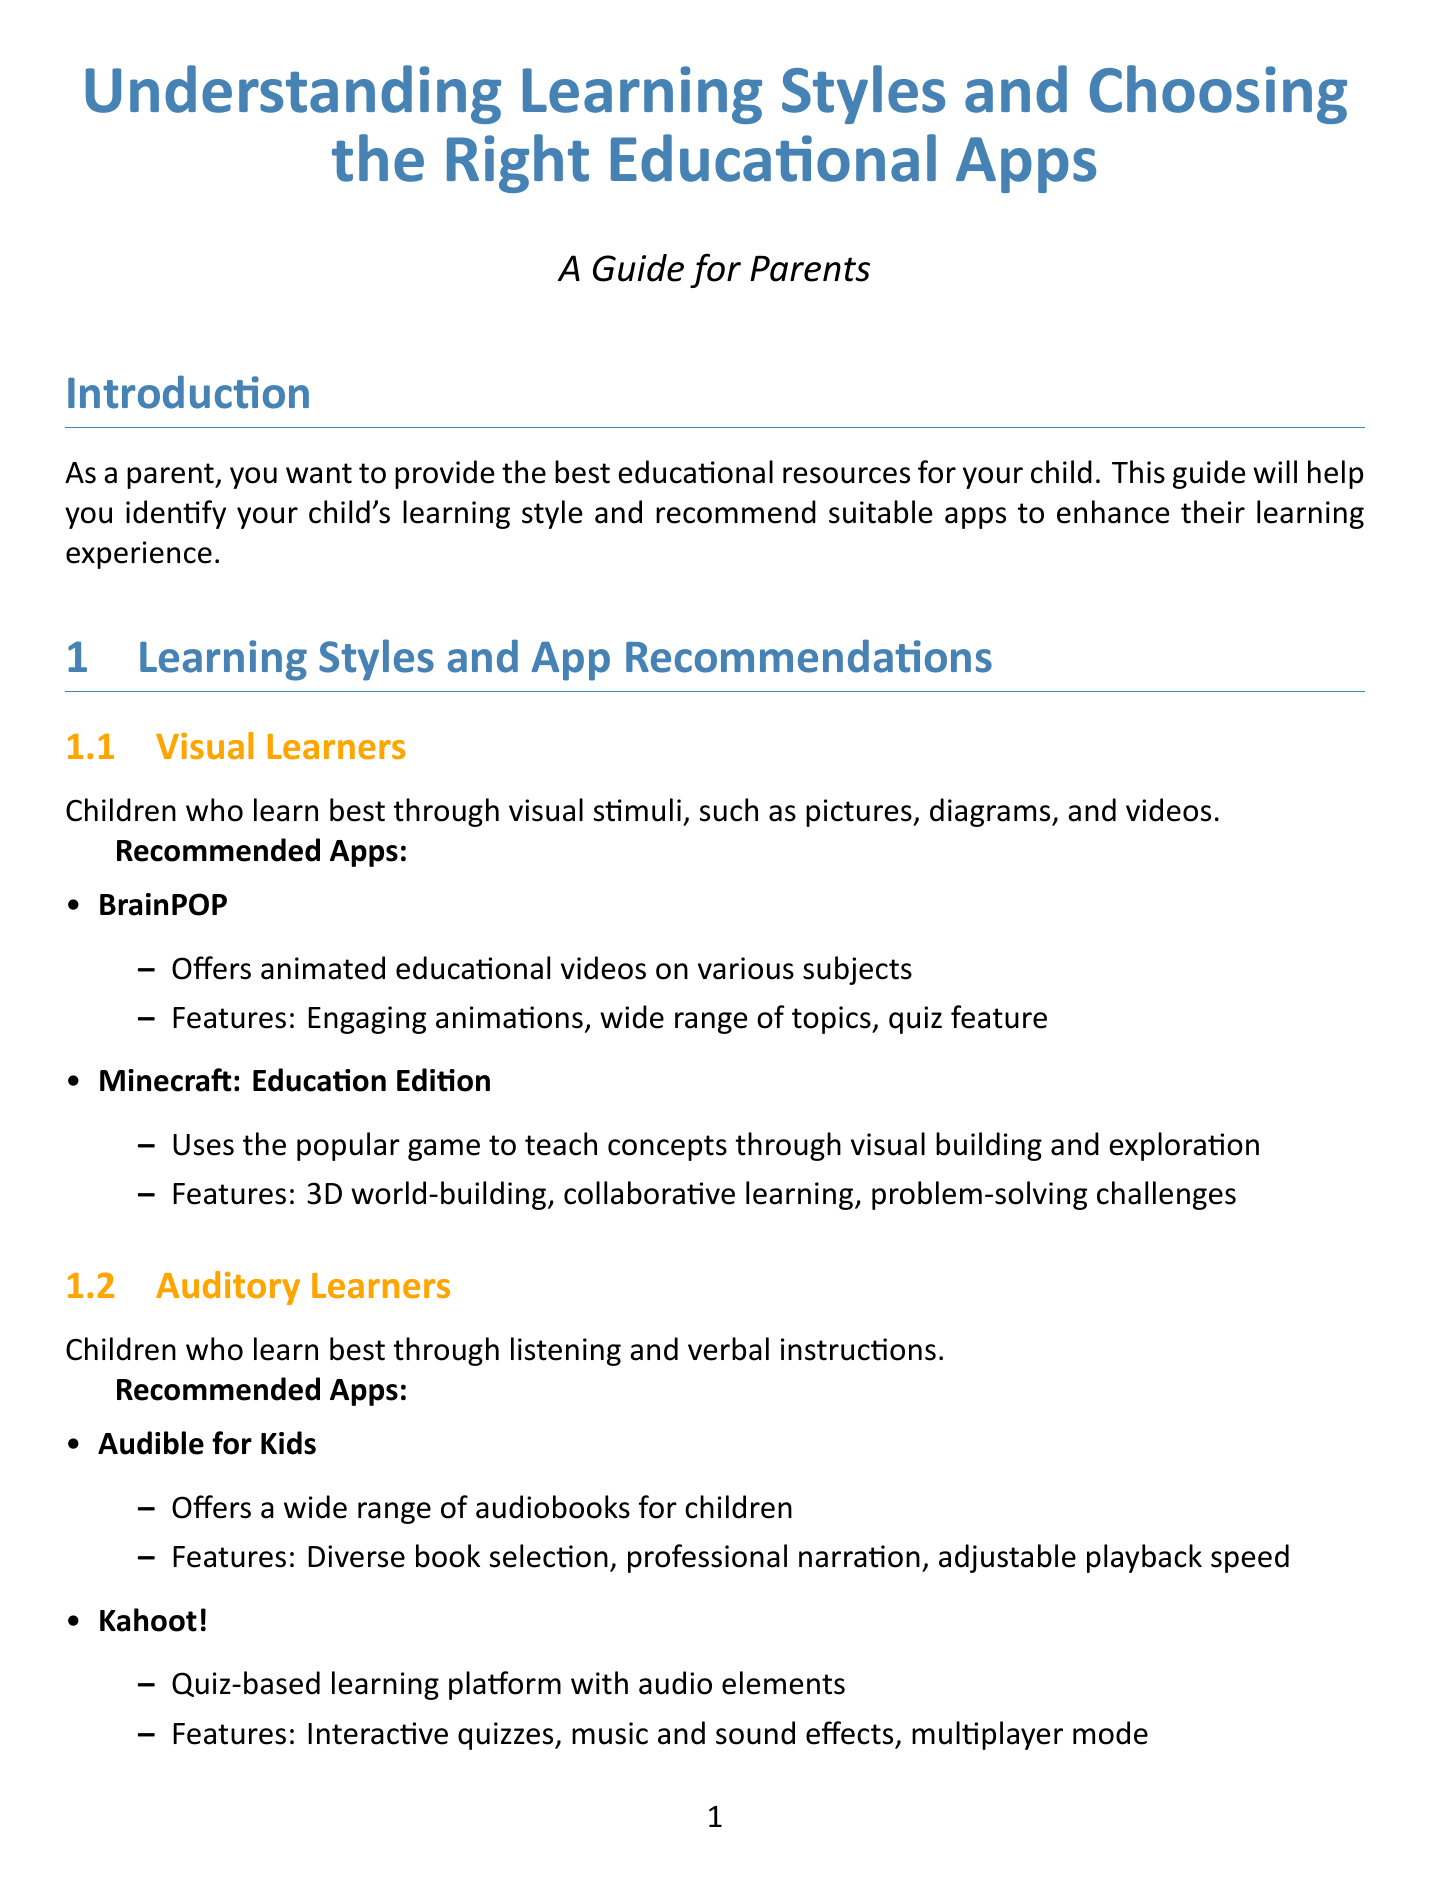What is the title of the guide? The title of the guide is stated directly at the beginning of the document.
Answer: Understanding Learning Styles and Choosing the Right Educational Apps How many learning styles are described in the document? The document lists multiple learning styles under a specific section.
Answer: Four What app is recommended for visual learners? The document provides specific recommendations for each learning style.
Answer: BrainPOP Which app combines physical objects with digital learning experiences? This question requires reasoning about the descriptions provided in the app recommendations for kinesthetic learners.
Answer: Osmo What is one feature of the app Epic!? The document lists features for the recommended apps, which includes this information.
Answer: Vast book collection What is the first step in choosing the right app? The document outlines specific steps for parents to choose suitable educational apps for their children.
Answer: Observe your child's preferred learning methods Which learning style learns best through listening? This is an information retrieval question asking for a specific group's preference from the document.
Answer: Auditory Learners What is one additional tip given for app usage? The document provides extra tips after the main recommendations, indicating further guidance for parents.
Answer: Rotate between apps to maintain interest and cover various subjects 